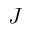Convert formula to latex. <formula><loc_0><loc_0><loc_500><loc_500>J</formula> 